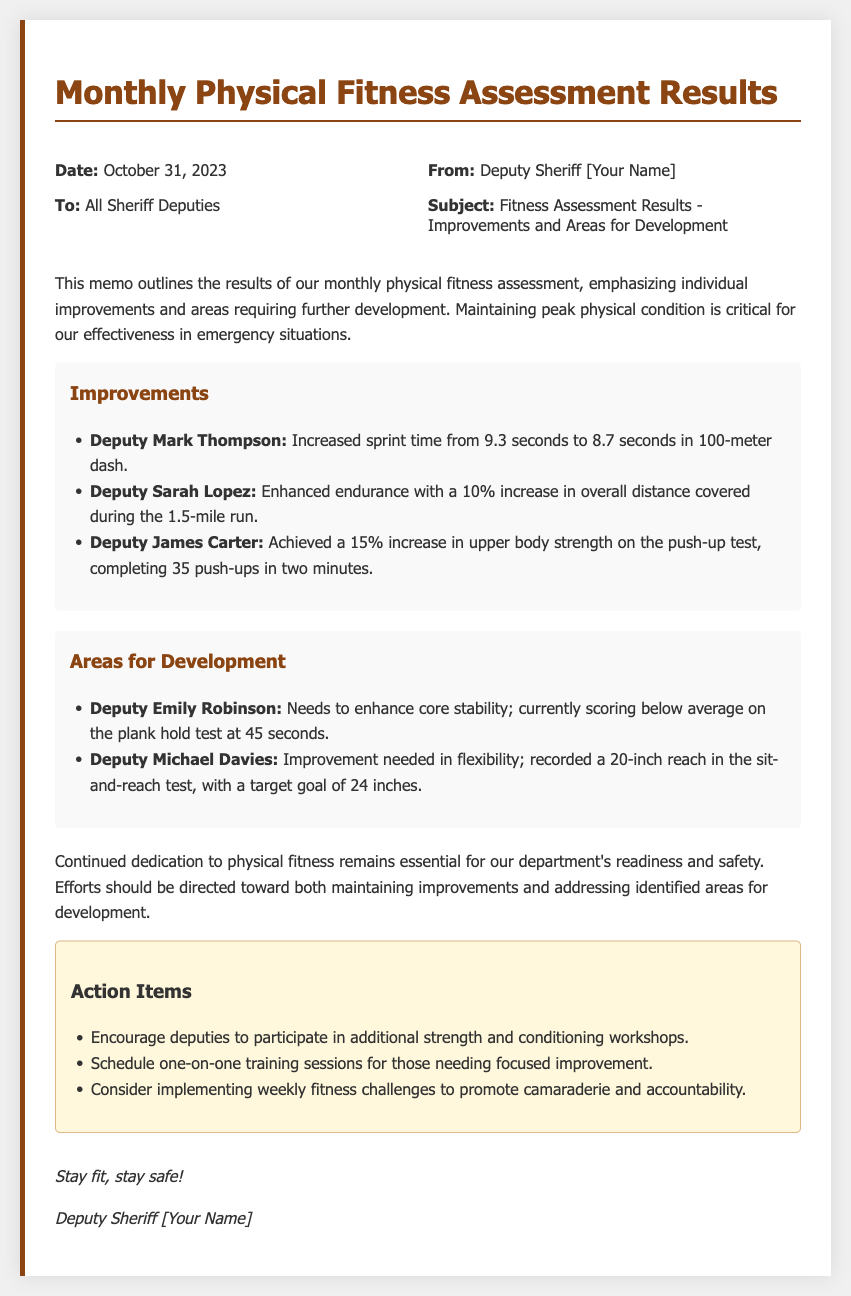What is the date of the memo? The date of the memo is provided in the header section, specifically indicating "October 31, 2023."
Answer: October 31, 2023 Who is the sender of the memo? The sender's name is found in the header section, listed as "Deputy Sheriff [Your Name]."
Answer: Deputy Sheriff [Your Name] What percentage increase did Deputy Sarah Lopez achieve in overall distance? The document states that Deputy Sarah Lopez achieved a "10% increase" in her performance.
Answer: 10% How many push-ups did Deputy James Carter complete in two minutes? The results for Deputy James Carter indicate that he completed "35 push-ups in two minutes."
Answer: 35 push-ups What is the average score for Deputy Emily Robinson on the plank hold test? The document specifies Deputy Emily Robinson's score, stating she is "currently scoring below average at 45 seconds."
Answer: 45 seconds What specific area does Deputy Michael Davies need to improve? The memo indicates that Deputy Michael Davies needs to improve in "flexibility."
Answer: Flexibility What is one of the suggested action items for deputies? The action items section lists several suggestions, one of which is to "encourage deputies to participate in additional strength and conditioning workshops."
Answer: Encourage deputies to participate in additional strength and conditioning workshops How long did the plank hold last for Deputy Emily Robinson? The memo notes that Deputy Emily Robinson held the plank position for "45 seconds."
Answer: 45 seconds 